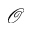<formula> <loc_0><loc_0><loc_500><loc_500>\mathcal { O }</formula> 